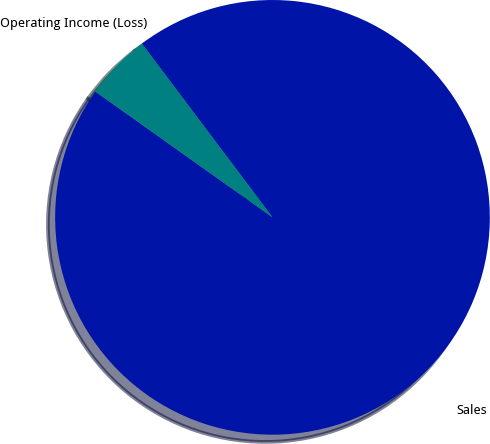<chart> <loc_0><loc_0><loc_500><loc_500><pie_chart><fcel>Sales<fcel>Operating Income (Loss)<nl><fcel>95.09%<fcel>4.91%<nl></chart> 